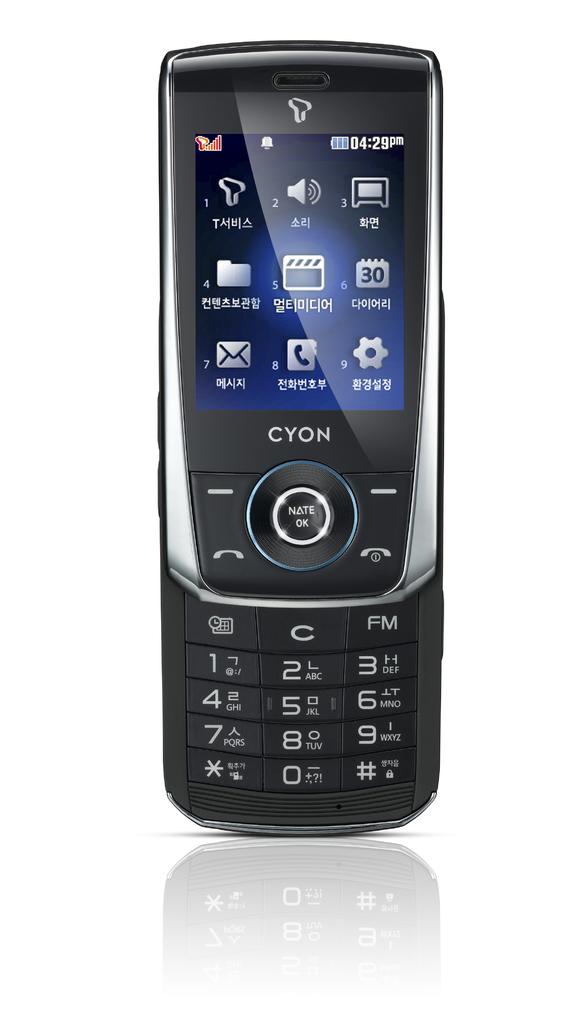What brand of phone is this?
Give a very brief answer. Cyon. What is written under the apps on the bottom row of the screen?
Provide a short and direct response. Cyon. 